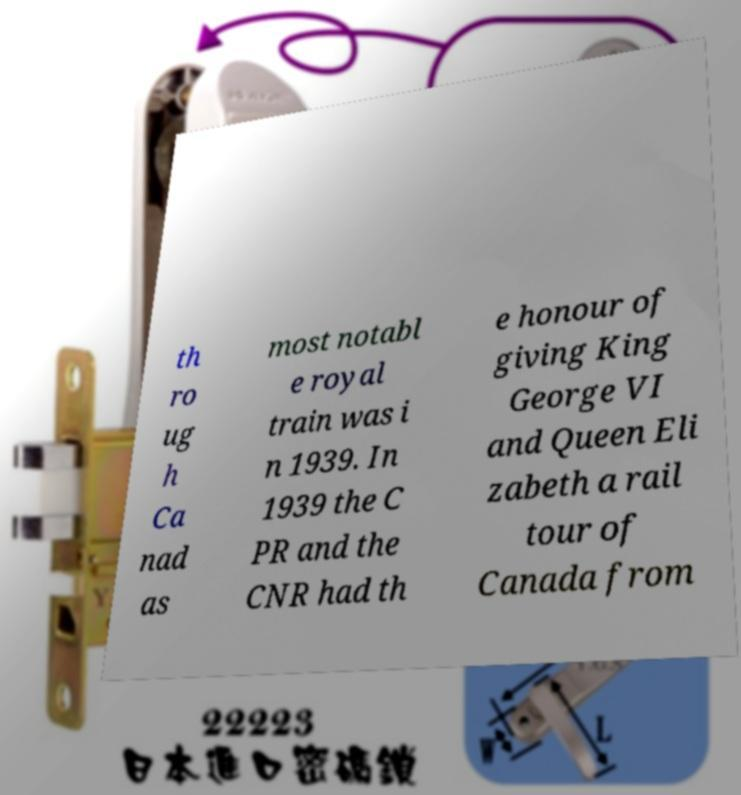Can you read and provide the text displayed in the image?This photo seems to have some interesting text. Can you extract and type it out for me? th ro ug h Ca nad as most notabl e royal train was i n 1939. In 1939 the C PR and the CNR had th e honour of giving King George VI and Queen Eli zabeth a rail tour of Canada from 